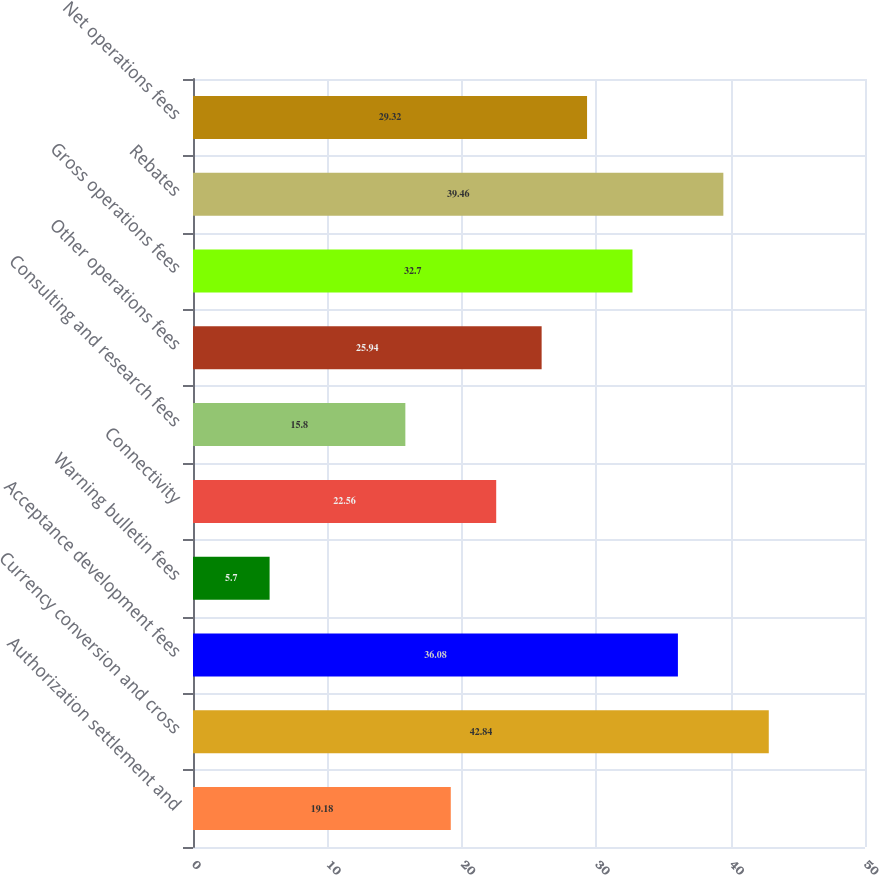Convert chart. <chart><loc_0><loc_0><loc_500><loc_500><bar_chart><fcel>Authorization settlement and<fcel>Currency conversion and cross<fcel>Acceptance development fees<fcel>Warning bulletin fees<fcel>Connectivity<fcel>Consulting and research fees<fcel>Other operations fees<fcel>Gross operations fees<fcel>Rebates<fcel>Net operations fees<nl><fcel>19.18<fcel>42.84<fcel>36.08<fcel>5.7<fcel>22.56<fcel>15.8<fcel>25.94<fcel>32.7<fcel>39.46<fcel>29.32<nl></chart> 